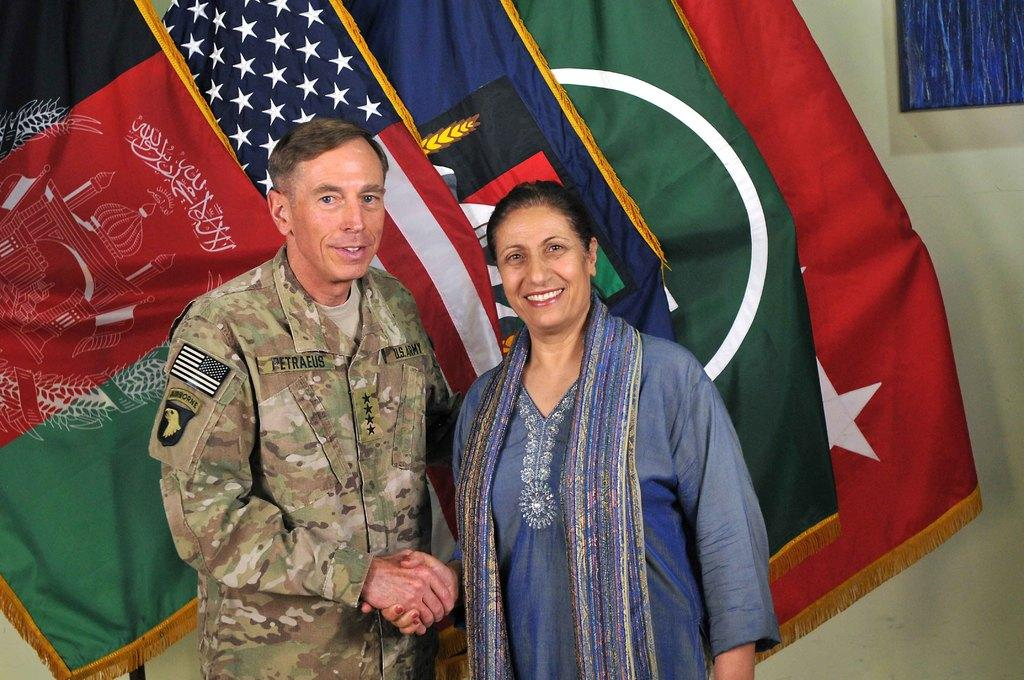How many people are in the image? There are two persons standing in the image. What is the facial expression of the persons? The persons are smiling. What can be seen behind the persons? There are flags visible behind the persons. What architectural feature is present in the background of the image? There is a wall with a window in the background of the image. What type of seat is visible in the image? There is no seat present in the image. What trade is being conducted in the image? There is no trade being conducted in the image; it simply features two smiling persons with flags in the background. 